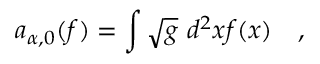Convert formula to latex. <formula><loc_0><loc_0><loc_500><loc_500>a _ { \alpha , 0 } ( f ) = \int \sqrt { g } d ^ { 2 } x f ( x ) ,</formula> 